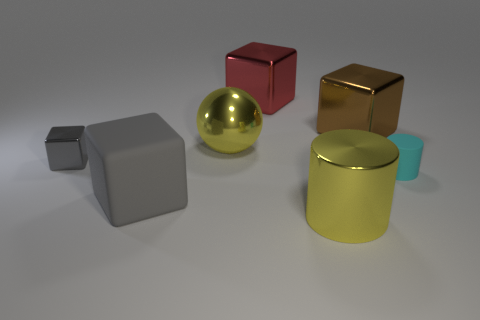Subtract all big rubber cubes. How many cubes are left? 3 Subtract all gray spheres. How many gray blocks are left? 2 Subtract 2 blocks. How many blocks are left? 2 Add 1 tiny purple shiny cylinders. How many objects exist? 8 Subtract all brown blocks. How many blocks are left? 3 Subtract all red blocks. Subtract all cyan cylinders. How many blocks are left? 3 Subtract all blocks. How many objects are left? 3 Add 6 tiny cyan rubber cylinders. How many tiny cyan rubber cylinders are left? 7 Add 4 large cyan cubes. How many large cyan cubes exist? 4 Subtract 0 blue blocks. How many objects are left? 7 